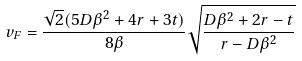<formula> <loc_0><loc_0><loc_500><loc_500>v _ { F } = \frac { \sqrt { 2 } ( 5 D \beta ^ { 2 } + 4 r + 3 t ) } { 8 \beta } \sqrt { \frac { D \beta ^ { 2 } + 2 r - t } { r - D \beta ^ { 2 } } }</formula> 